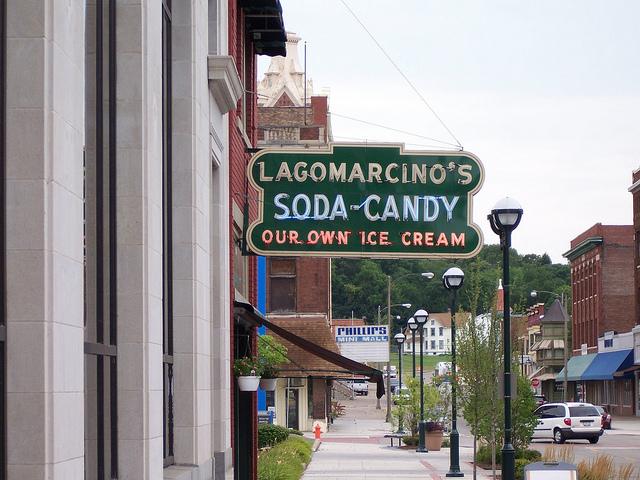What is written on the hanging sign?
Give a very brief answer. Lagomarcino's soda candy our own ice cream. What does the sign say?
Be succinct. Lagomarcino's soda candy. What kind of store is behind the sign?
Write a very short answer. Ice cream. How is the sign facing?
Answer briefly. Sideways. Does the store sell candy?
Give a very brief answer. Yes. What type of store is this?
Keep it brief. Ice cream parlor. What color is the sign?
Answer briefly. Green. What kind of shop is this?
Short answer required. Ice cream. Who is the sign intended for?
Quick response, please. Customers. What store is this?
Give a very brief answer. Lagomarcino's. What is the name of the restaurant?
Answer briefly. Lagomarcino's. How many flags do you see?
Concise answer only. 0. What does Lagomarcino's sell?
Concise answer only. Ice cream. 